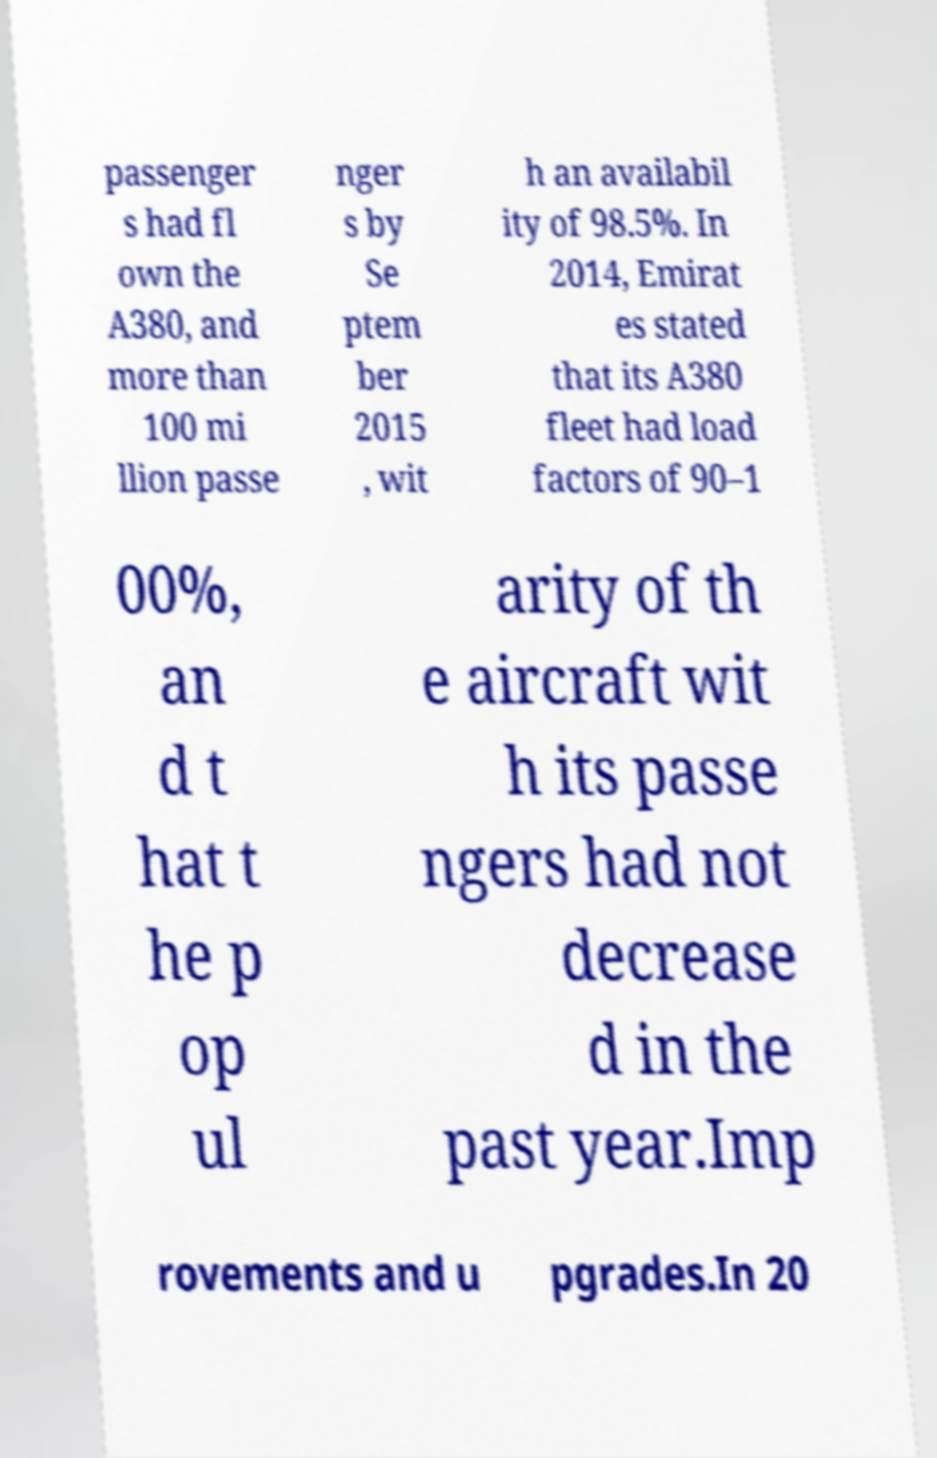There's text embedded in this image that I need extracted. Can you transcribe it verbatim? passenger s had fl own the A380, and more than 100 mi llion passe nger s by Se ptem ber 2015 , wit h an availabil ity of 98.5%. In 2014, Emirat es stated that its A380 fleet had load factors of 90–1 00%, an d t hat t he p op ul arity of th e aircraft wit h its passe ngers had not decrease d in the past year.Imp rovements and u pgrades.In 20 